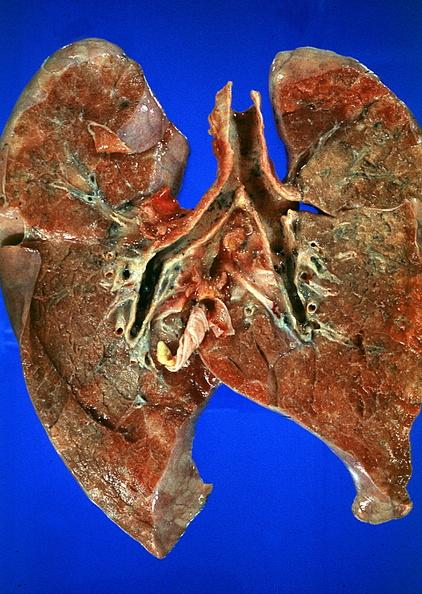what does this image show?
Answer the question using a single word or phrase. Lung 